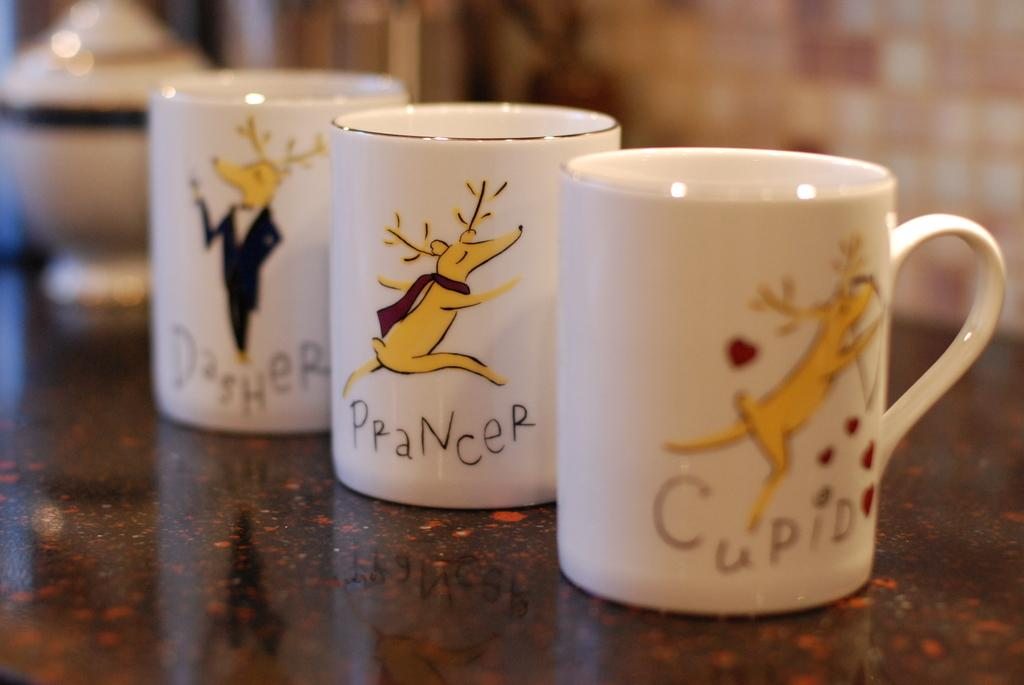What objects are on the surface in the image? There are mugs on a surface in the image. What can be seen in the background of the image? There is a wall in the background of the image. How does the zebra interact with the mugs in the image? There is no zebra present in the image, so it cannot interact with the mugs. 